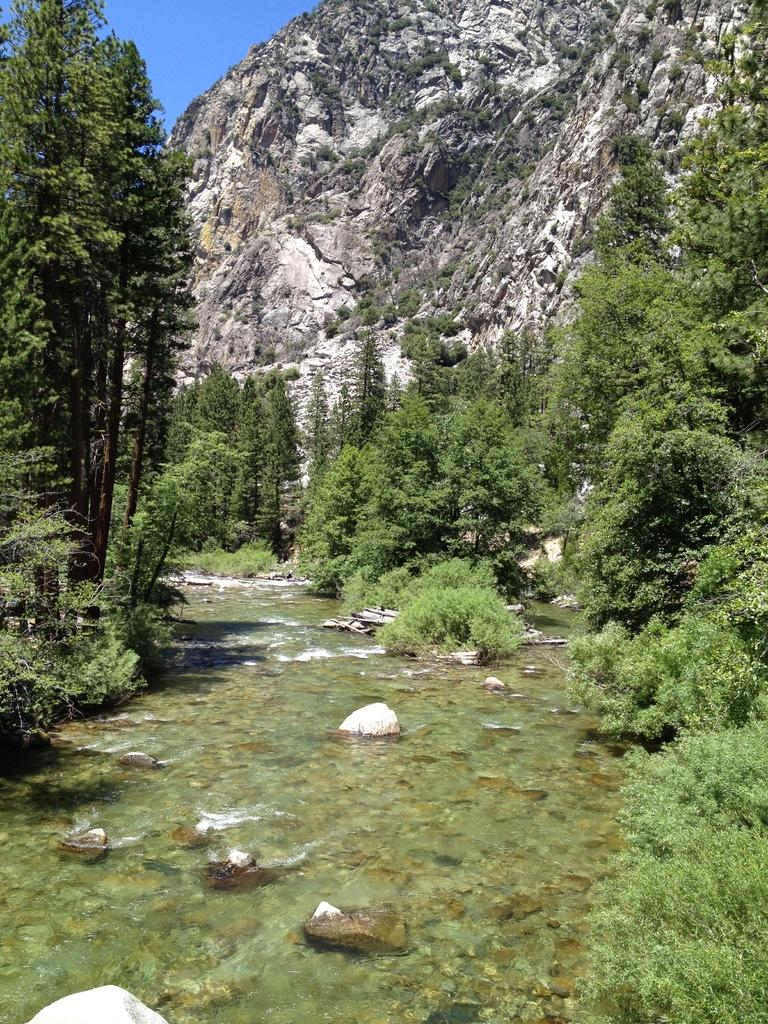What is present at the bottom of the image? There is water at the bottom side of the image. What type of vegetation or plants can be seen in the image? There is greenery in the image. What geographical feature is visible in the background of the image? There is a mountain in the background area of the image. Where is the shop located in the image? There is no shop present in the image. What type of action is being performed by the greenery in the image? The greenery is not performing any action in the image; it is stationary vegetation. 